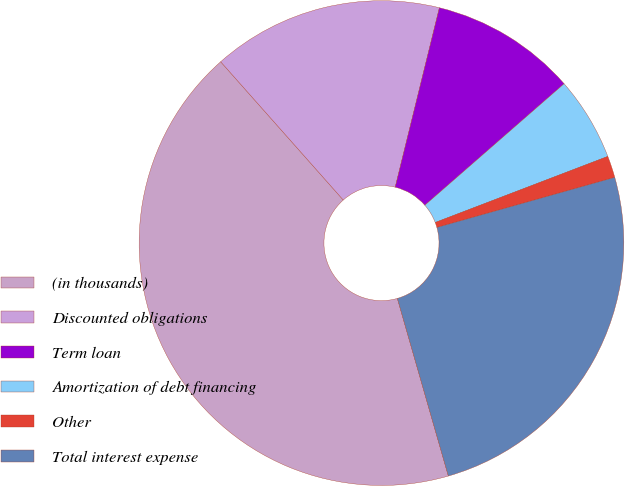Convert chart to OTSL. <chart><loc_0><loc_0><loc_500><loc_500><pie_chart><fcel>(in thousands)<fcel>Discounted obligations<fcel>Term loan<fcel>Amortization of debt financing<fcel>Other<fcel>Total interest expense<nl><fcel>42.91%<fcel>15.39%<fcel>9.74%<fcel>5.6%<fcel>1.45%<fcel>24.92%<nl></chart> 